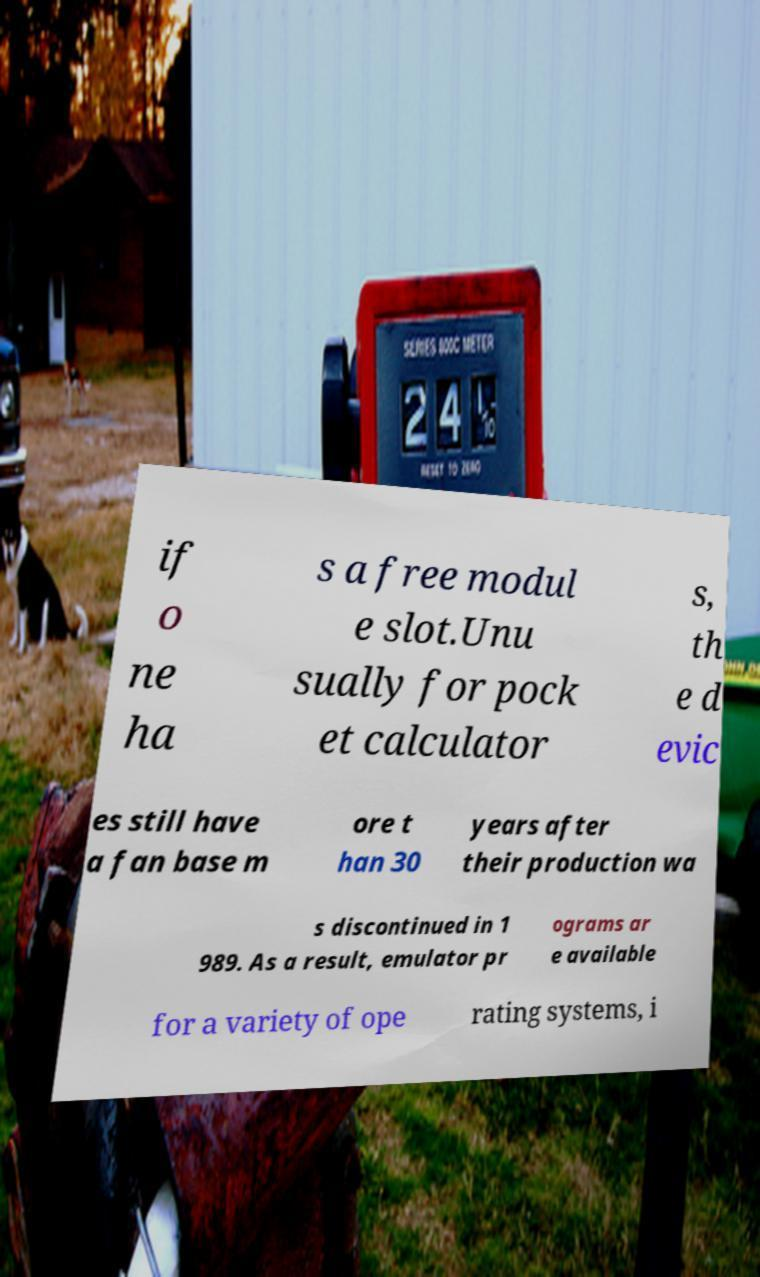Please identify and transcribe the text found in this image. if o ne ha s a free modul e slot.Unu sually for pock et calculator s, th e d evic es still have a fan base m ore t han 30 years after their production wa s discontinued in 1 989. As a result, emulator pr ograms ar e available for a variety of ope rating systems, i 